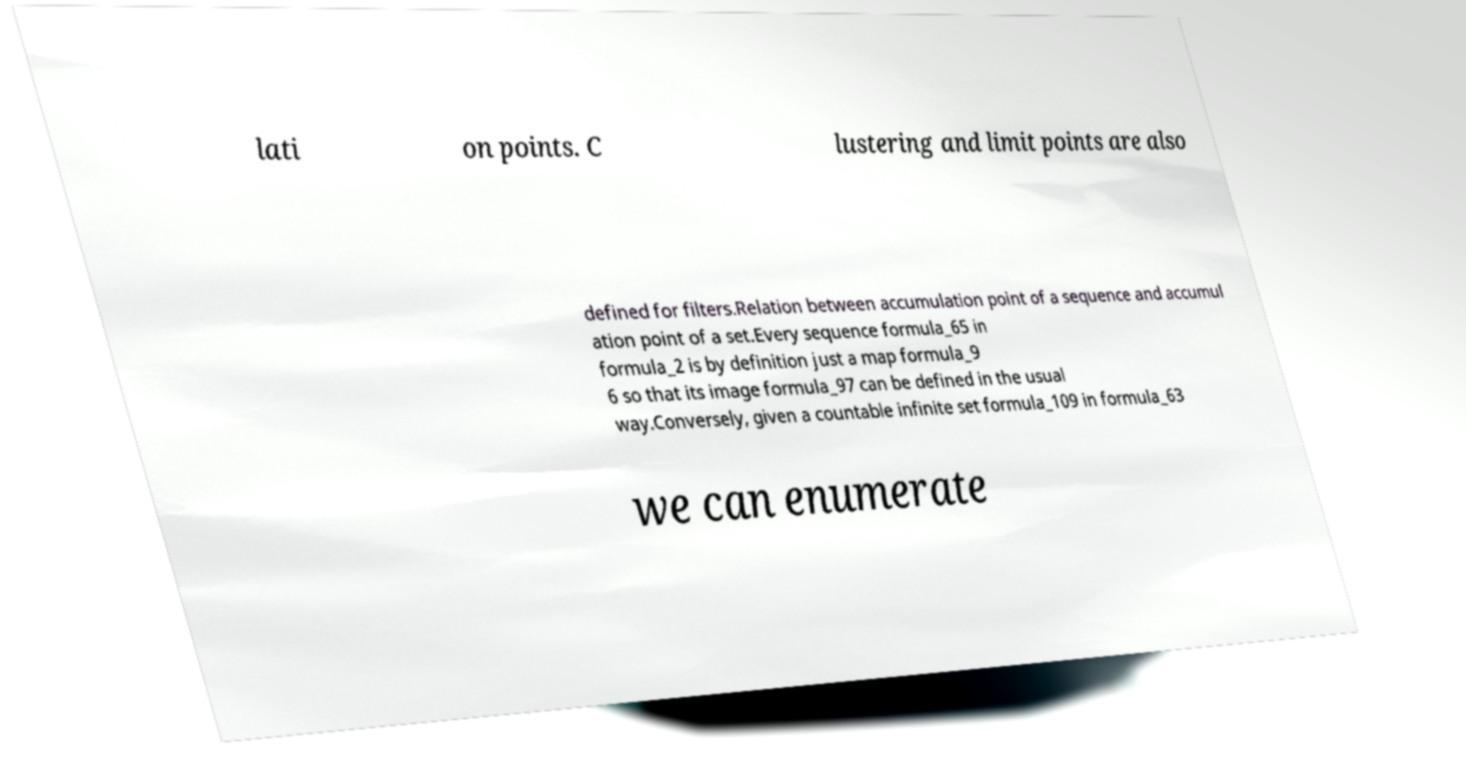Could you assist in decoding the text presented in this image and type it out clearly? lati on points. C lustering and limit points are also defined for filters.Relation between accumulation point of a sequence and accumul ation point of a set.Every sequence formula_65 in formula_2 is by definition just a map formula_9 6 so that its image formula_97 can be defined in the usual way.Conversely, given a countable infinite set formula_109 in formula_63 we can enumerate 